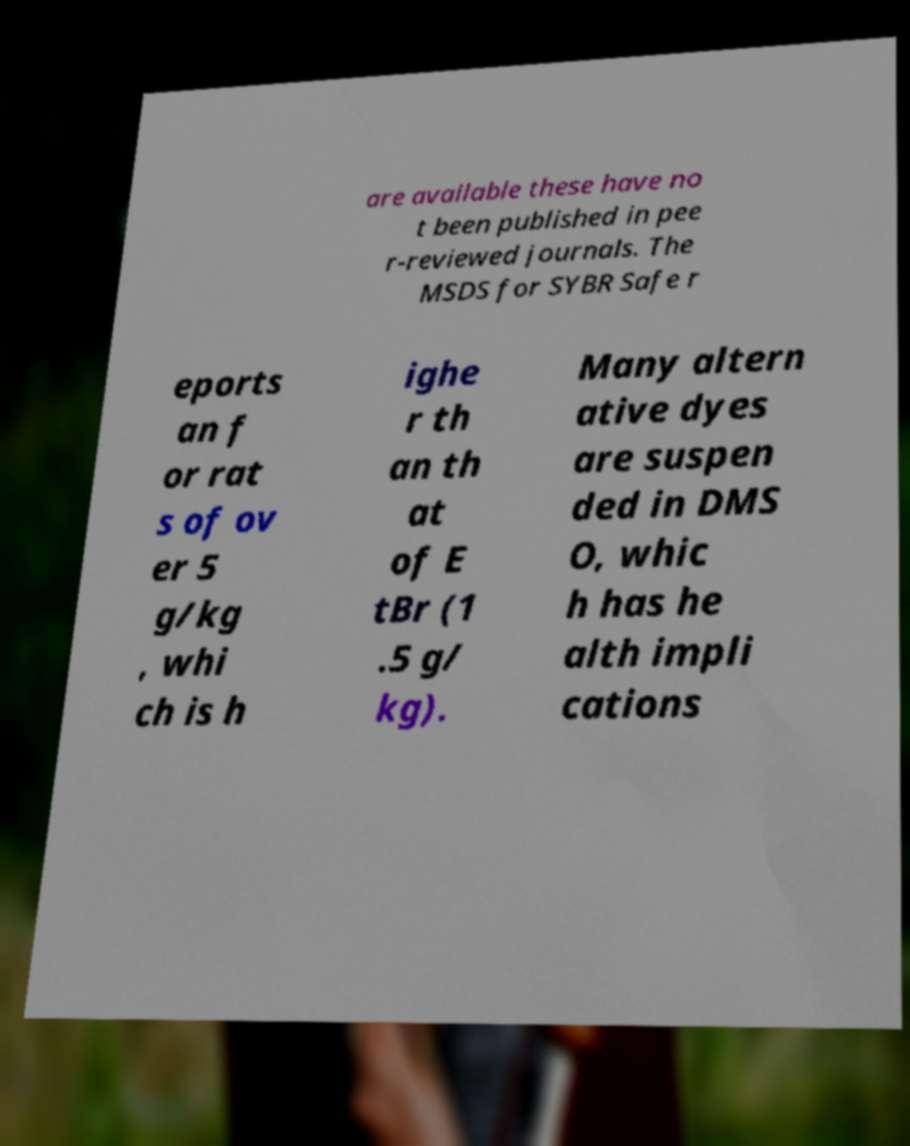Can you read and provide the text displayed in the image?This photo seems to have some interesting text. Can you extract and type it out for me? are available these have no t been published in pee r-reviewed journals. The MSDS for SYBR Safe r eports an f or rat s of ov er 5 g/kg , whi ch is h ighe r th an th at of E tBr (1 .5 g/ kg). Many altern ative dyes are suspen ded in DMS O, whic h has he alth impli cations 